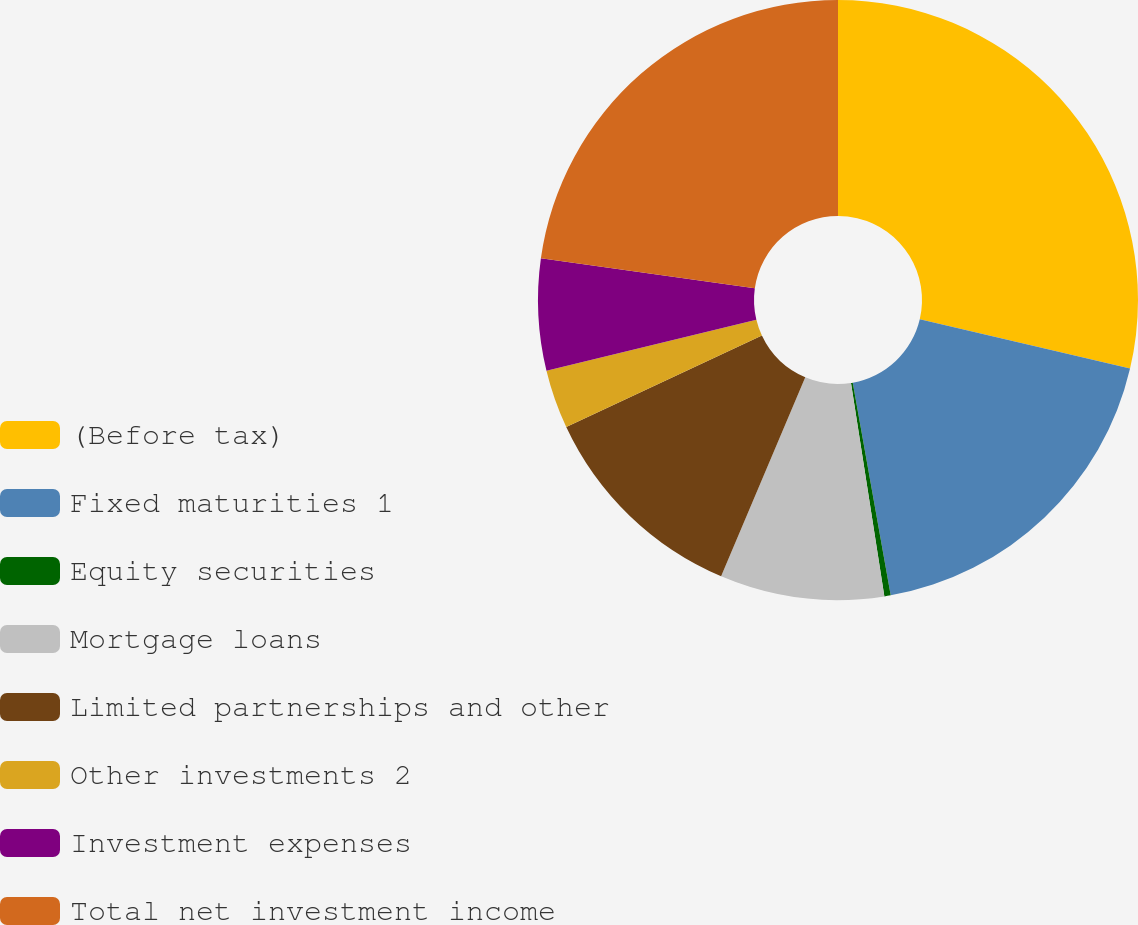Convert chart to OTSL. <chart><loc_0><loc_0><loc_500><loc_500><pie_chart><fcel>(Before tax)<fcel>Fixed maturities 1<fcel>Equity securities<fcel>Mortgage loans<fcel>Limited partnerships and other<fcel>Other investments 2<fcel>Investment expenses<fcel>Total net investment income<nl><fcel>28.67%<fcel>18.52%<fcel>0.34%<fcel>8.84%<fcel>11.67%<fcel>3.17%<fcel>6.01%<fcel>22.78%<nl></chart> 